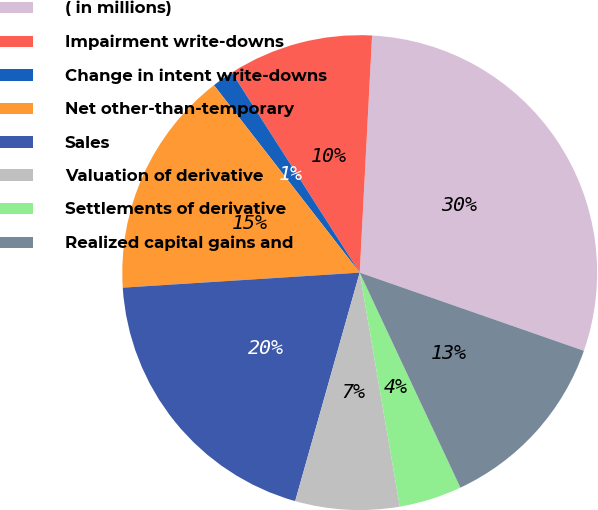<chart> <loc_0><loc_0><loc_500><loc_500><pie_chart><fcel>( in millions)<fcel>Impairment write-downs<fcel>Change in intent write-downs<fcel>Net other-than-temporary<fcel>Sales<fcel>Valuation of derivative<fcel>Settlements of derivative<fcel>Realized capital gains and<nl><fcel>29.51%<fcel>9.88%<fcel>1.47%<fcel>15.49%<fcel>19.61%<fcel>7.08%<fcel>4.27%<fcel>12.69%<nl></chart> 